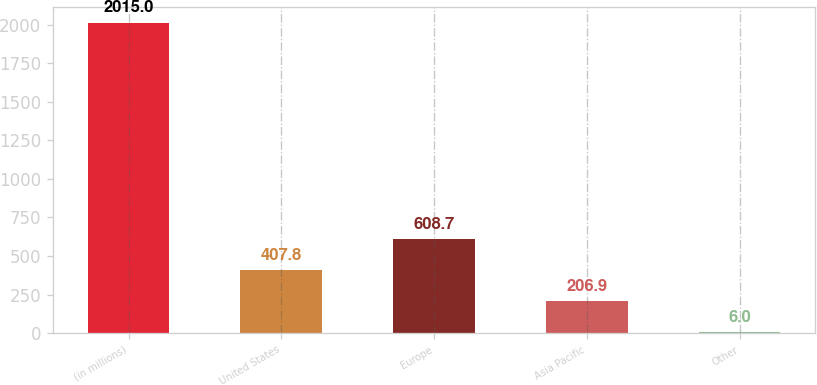<chart> <loc_0><loc_0><loc_500><loc_500><bar_chart><fcel>(in millions)<fcel>United States<fcel>Europe<fcel>Asia Pacific<fcel>Other<nl><fcel>2015<fcel>407.8<fcel>608.7<fcel>206.9<fcel>6<nl></chart> 